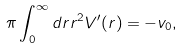Convert formula to latex. <formula><loc_0><loc_0><loc_500><loc_500>\pi \int _ { 0 } ^ { \infty } d r r ^ { 2 } V ^ { \prime } ( r ) = - v _ { 0 } ,</formula> 